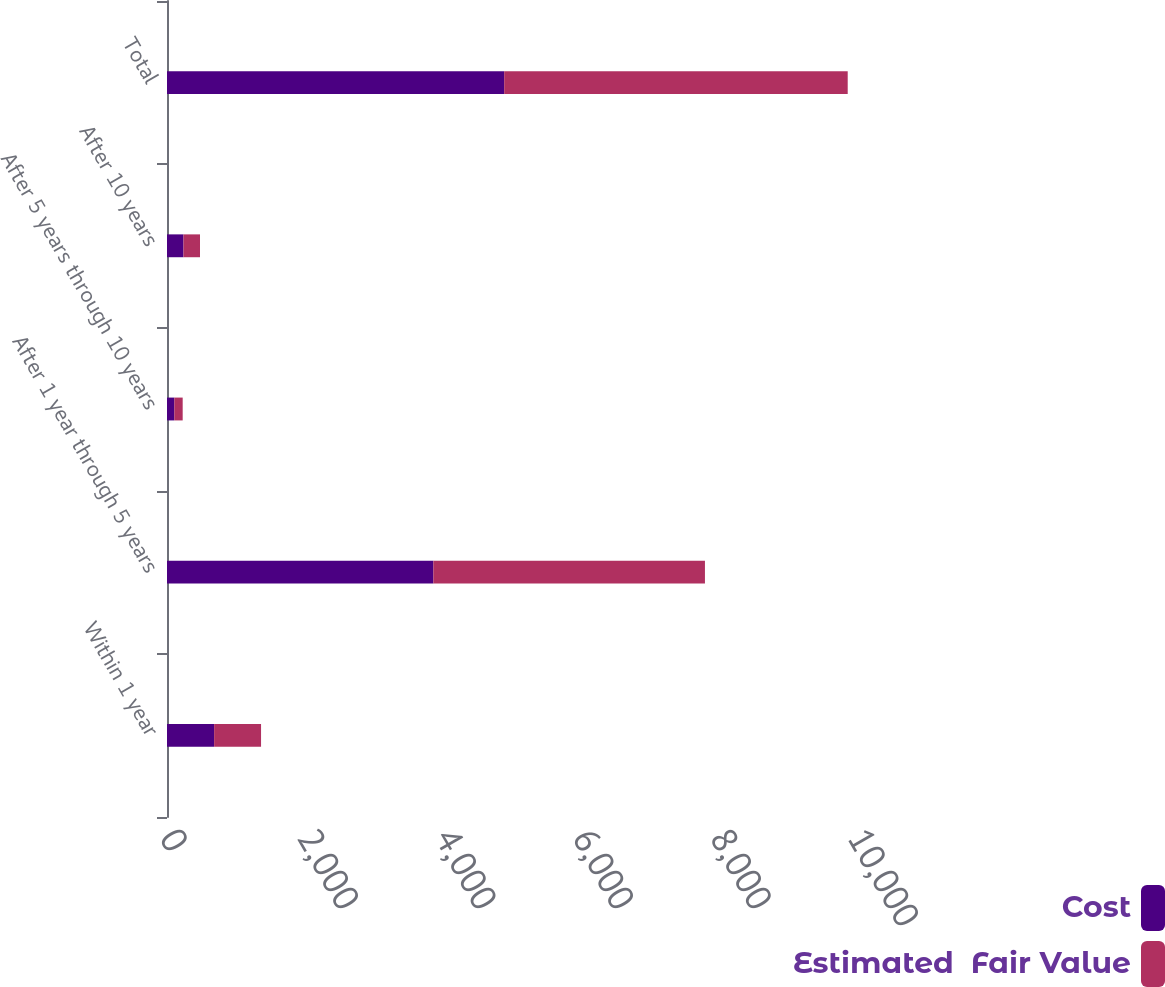Convert chart. <chart><loc_0><loc_0><loc_500><loc_500><stacked_bar_chart><ecel><fcel>Within 1 year<fcel>After 1 year through 5 years<fcel>After 5 years through 10 years<fcel>After 10 years<fcel>Total<nl><fcel>Cost<fcel>685<fcel>3871<fcel>106<fcel>239<fcel>4901<nl><fcel>Estimated  Fair Value<fcel>682<fcel>3948<fcel>122<fcel>241<fcel>4993<nl></chart> 